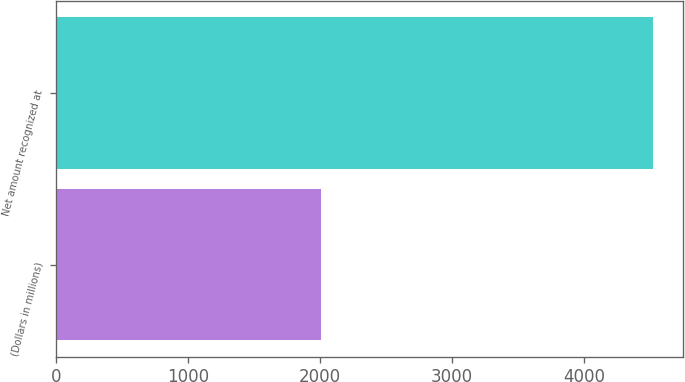Convert chart to OTSL. <chart><loc_0><loc_0><loc_500><loc_500><bar_chart><fcel>(Dollars in millions)<fcel>Net amount recognized at<nl><fcel>2007<fcel>4520<nl></chart> 